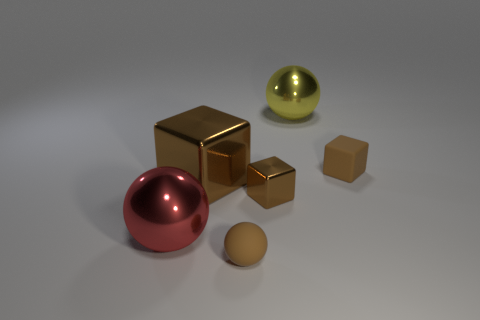Subtract all brown blocks. How many were subtracted if there are1brown blocks left? 2 Subtract all tiny brown blocks. How many blocks are left? 1 Add 2 tiny yellow metallic things. How many objects exist? 8 Subtract all red cubes. Subtract all brown cylinders. How many cubes are left? 3 Add 3 tiny brown rubber cubes. How many tiny brown rubber cubes are left? 4 Add 3 big gray matte spheres. How many big gray matte spheres exist? 3 Subtract 2 brown blocks. How many objects are left? 4 Subtract all red balls. Subtract all tiny brown shiny blocks. How many objects are left? 4 